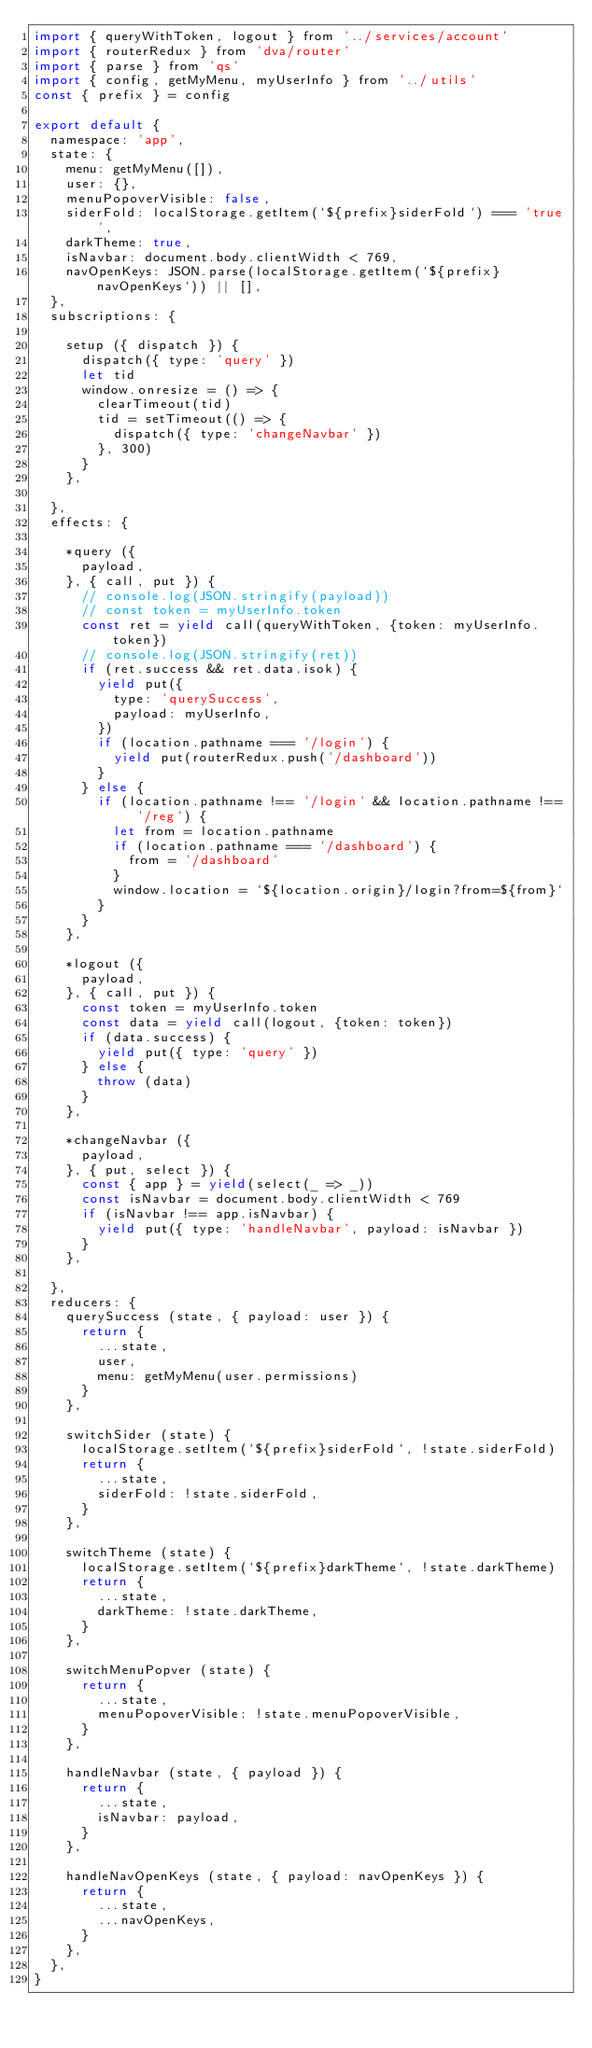<code> <loc_0><loc_0><loc_500><loc_500><_JavaScript_>import { queryWithToken, logout } from '../services/account'
import { routerRedux } from 'dva/router'
import { parse } from 'qs'
import { config, getMyMenu, myUserInfo } from '../utils'
const { prefix } = config

export default {
  namespace: 'app',
  state: {
    menu: getMyMenu([]),
    user: {},
    menuPopoverVisible: false,
    siderFold: localStorage.getItem(`${prefix}siderFold`) === 'true',
    darkTheme: true,
    isNavbar: document.body.clientWidth < 769,
    navOpenKeys: JSON.parse(localStorage.getItem(`${prefix}navOpenKeys`)) || [],
  },
  subscriptions: {

    setup ({ dispatch }) {
      dispatch({ type: 'query' })
      let tid
      window.onresize = () => {
        clearTimeout(tid)
        tid = setTimeout(() => {
          dispatch({ type: 'changeNavbar' })
        }, 300)
      }
    },

  },
  effects: {

    *query ({
      payload,
    }, { call, put }) {
      // console.log(JSON.stringify(payload))
      // const token = myUserInfo.token
      const ret = yield call(queryWithToken, {token: myUserInfo.token})
      // console.log(JSON.stringify(ret))
      if (ret.success && ret.data.isok) {
        yield put({
          type: 'querySuccess',
          payload: myUserInfo,
        })
        if (location.pathname === '/login') {
          yield put(routerRedux.push('/dashboard'))
        }
      } else {
        if (location.pathname !== '/login' && location.pathname !== '/reg') {
          let from = location.pathname
          if (location.pathname === '/dashboard') {
            from = '/dashboard'
          }
          window.location = `${location.origin}/login?from=${from}`
        }
      }
    },

    *logout ({
      payload,
    }, { call, put }) {
      const token = myUserInfo.token
      const data = yield call(logout, {token: token})
      if (data.success) {
        yield put({ type: 'query' })
      } else {
        throw (data)
      }
    },

    *changeNavbar ({
      payload,
    }, { put, select }) {
      const { app } = yield(select(_ => _))
      const isNavbar = document.body.clientWidth < 769
      if (isNavbar !== app.isNavbar) {
        yield put({ type: 'handleNavbar', payload: isNavbar })
      }
    },

  },
  reducers: {
    querySuccess (state, { payload: user }) {
      return {
        ...state,
        user,
        menu: getMyMenu(user.permissions)
      }
    },

    switchSider (state) {
      localStorage.setItem(`${prefix}siderFold`, !state.siderFold)
      return {
        ...state,
        siderFold: !state.siderFold,
      }
    },

    switchTheme (state) {
      localStorage.setItem(`${prefix}darkTheme`, !state.darkTheme)
      return {
        ...state,
        darkTheme: !state.darkTheme,
      }
    },

    switchMenuPopver (state) {
      return {
        ...state,
        menuPopoverVisible: !state.menuPopoverVisible,
      }
    },

    handleNavbar (state, { payload }) {
      return {
        ...state,
        isNavbar: payload,
      }
    },

    handleNavOpenKeys (state, { payload: navOpenKeys }) {
      return {
        ...state,
        ...navOpenKeys,
      }
    },
  },
}
</code> 